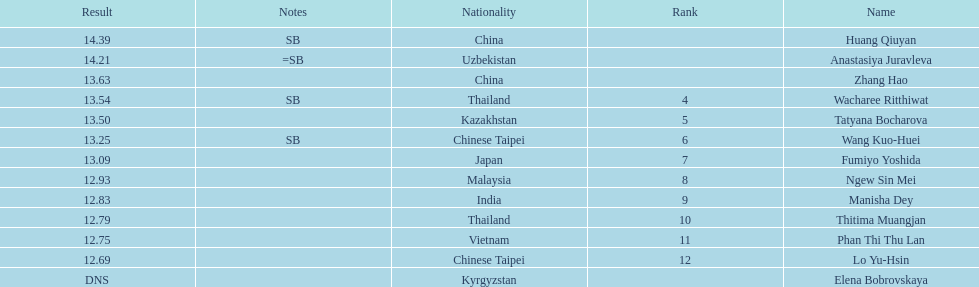What is the difference between huang qiuyan's result and fumiyo yoshida's result? 1.3. 